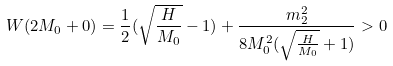Convert formula to latex. <formula><loc_0><loc_0><loc_500><loc_500>W ( 2 M _ { 0 } + 0 ) = \frac { 1 } { 2 } ( \sqrt { \frac { H } { M _ { 0 } } } - 1 ) + \frac { m _ { 2 } ^ { 2 } } { 8 M ^ { 2 } _ { 0 } ( \sqrt { \frac { H } { M _ { 0 } } } + 1 ) } > 0</formula> 